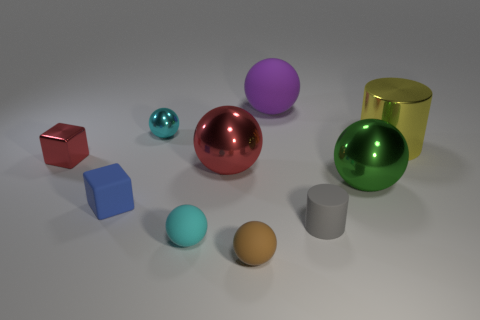Imagine these objects were part of a modern art installation. What might the theme or message be? If these objects were part of a modern art installation, the theme could be 'Variety in Unity.' Each object, with its unique shape and color, represents diversity. Yet, they are united by the commonality of being simple, solid geometric forms, thus reflecting on the beauty and harmony that can be found in diversity within the broader unified context. 